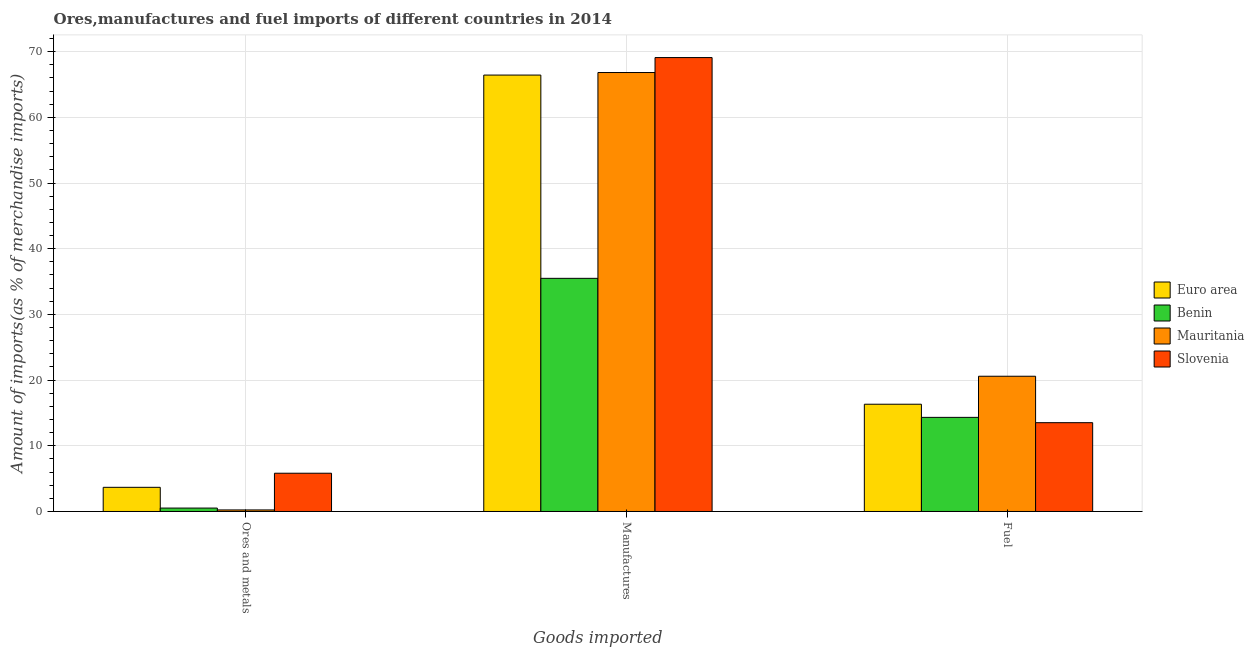How many groups of bars are there?
Your response must be concise. 3. Are the number of bars per tick equal to the number of legend labels?
Your answer should be compact. Yes. How many bars are there on the 2nd tick from the right?
Provide a succinct answer. 4. What is the label of the 2nd group of bars from the left?
Keep it short and to the point. Manufactures. What is the percentage of fuel imports in Slovenia?
Provide a short and direct response. 13.52. Across all countries, what is the maximum percentage of fuel imports?
Provide a succinct answer. 20.59. Across all countries, what is the minimum percentage of fuel imports?
Your response must be concise. 13.52. In which country was the percentage of manufactures imports maximum?
Keep it short and to the point. Slovenia. In which country was the percentage of ores and metals imports minimum?
Offer a very short reply. Mauritania. What is the total percentage of ores and metals imports in the graph?
Offer a terse response. 10.26. What is the difference between the percentage of ores and metals imports in Benin and that in Mauritania?
Ensure brevity in your answer.  0.28. What is the difference between the percentage of manufactures imports in Mauritania and the percentage of ores and metals imports in Benin?
Give a very brief answer. 66.3. What is the average percentage of fuel imports per country?
Ensure brevity in your answer.  16.19. What is the difference between the percentage of manufactures imports and percentage of fuel imports in Slovenia?
Make the answer very short. 55.58. What is the ratio of the percentage of fuel imports in Euro area to that in Slovenia?
Offer a very short reply. 1.21. Is the percentage of manufactures imports in Euro area less than that in Mauritania?
Make the answer very short. Yes. What is the difference between the highest and the second highest percentage of manufactures imports?
Keep it short and to the point. 2.28. What is the difference between the highest and the lowest percentage of manufactures imports?
Provide a succinct answer. 33.61. In how many countries, is the percentage of ores and metals imports greater than the average percentage of ores and metals imports taken over all countries?
Provide a short and direct response. 2. Is the sum of the percentage of manufactures imports in Benin and Slovenia greater than the maximum percentage of ores and metals imports across all countries?
Offer a very short reply. Yes. What does the 3rd bar from the left in Manufactures represents?
Ensure brevity in your answer.  Mauritania. What does the 1st bar from the right in Ores and metals represents?
Your answer should be compact. Slovenia. Are all the bars in the graph horizontal?
Provide a succinct answer. No. How many countries are there in the graph?
Provide a short and direct response. 4. Are the values on the major ticks of Y-axis written in scientific E-notation?
Provide a short and direct response. No. Does the graph contain any zero values?
Keep it short and to the point. No. How many legend labels are there?
Make the answer very short. 4. How are the legend labels stacked?
Your response must be concise. Vertical. What is the title of the graph?
Your answer should be very brief. Ores,manufactures and fuel imports of different countries in 2014. What is the label or title of the X-axis?
Your answer should be compact. Goods imported. What is the label or title of the Y-axis?
Offer a terse response. Amount of imports(as % of merchandise imports). What is the Amount of imports(as % of merchandise imports) in Euro area in Ores and metals?
Make the answer very short. 3.68. What is the Amount of imports(as % of merchandise imports) of Benin in Ores and metals?
Offer a terse response. 0.52. What is the Amount of imports(as % of merchandise imports) in Mauritania in Ores and metals?
Give a very brief answer. 0.24. What is the Amount of imports(as % of merchandise imports) of Slovenia in Ores and metals?
Offer a very short reply. 5.82. What is the Amount of imports(as % of merchandise imports) of Euro area in Manufactures?
Provide a short and direct response. 66.44. What is the Amount of imports(as % of merchandise imports) in Benin in Manufactures?
Ensure brevity in your answer.  35.49. What is the Amount of imports(as % of merchandise imports) in Mauritania in Manufactures?
Make the answer very short. 66.82. What is the Amount of imports(as % of merchandise imports) in Slovenia in Manufactures?
Ensure brevity in your answer.  69.1. What is the Amount of imports(as % of merchandise imports) of Euro area in Fuel?
Provide a short and direct response. 16.33. What is the Amount of imports(as % of merchandise imports) in Benin in Fuel?
Ensure brevity in your answer.  14.33. What is the Amount of imports(as % of merchandise imports) in Mauritania in Fuel?
Provide a succinct answer. 20.59. What is the Amount of imports(as % of merchandise imports) of Slovenia in Fuel?
Ensure brevity in your answer.  13.52. Across all Goods imported, what is the maximum Amount of imports(as % of merchandise imports) in Euro area?
Make the answer very short. 66.44. Across all Goods imported, what is the maximum Amount of imports(as % of merchandise imports) in Benin?
Provide a succinct answer. 35.49. Across all Goods imported, what is the maximum Amount of imports(as % of merchandise imports) in Mauritania?
Your response must be concise. 66.82. Across all Goods imported, what is the maximum Amount of imports(as % of merchandise imports) in Slovenia?
Offer a terse response. 69.1. Across all Goods imported, what is the minimum Amount of imports(as % of merchandise imports) in Euro area?
Provide a succinct answer. 3.68. Across all Goods imported, what is the minimum Amount of imports(as % of merchandise imports) in Benin?
Provide a short and direct response. 0.52. Across all Goods imported, what is the minimum Amount of imports(as % of merchandise imports) of Mauritania?
Make the answer very short. 0.24. Across all Goods imported, what is the minimum Amount of imports(as % of merchandise imports) in Slovenia?
Provide a short and direct response. 5.82. What is the total Amount of imports(as % of merchandise imports) of Euro area in the graph?
Your answer should be compact. 86.44. What is the total Amount of imports(as % of merchandise imports) of Benin in the graph?
Provide a succinct answer. 50.34. What is the total Amount of imports(as % of merchandise imports) of Mauritania in the graph?
Make the answer very short. 87.64. What is the total Amount of imports(as % of merchandise imports) in Slovenia in the graph?
Provide a succinct answer. 88.44. What is the difference between the Amount of imports(as % of merchandise imports) in Euro area in Ores and metals and that in Manufactures?
Make the answer very short. -62.76. What is the difference between the Amount of imports(as % of merchandise imports) of Benin in Ores and metals and that in Manufactures?
Your answer should be compact. -34.97. What is the difference between the Amount of imports(as % of merchandise imports) in Mauritania in Ores and metals and that in Manufactures?
Provide a short and direct response. -66.59. What is the difference between the Amount of imports(as % of merchandise imports) of Slovenia in Ores and metals and that in Manufactures?
Keep it short and to the point. -63.27. What is the difference between the Amount of imports(as % of merchandise imports) in Euro area in Ores and metals and that in Fuel?
Keep it short and to the point. -12.65. What is the difference between the Amount of imports(as % of merchandise imports) in Benin in Ores and metals and that in Fuel?
Make the answer very short. -13.81. What is the difference between the Amount of imports(as % of merchandise imports) in Mauritania in Ores and metals and that in Fuel?
Offer a terse response. -20.35. What is the difference between the Amount of imports(as % of merchandise imports) of Slovenia in Ores and metals and that in Fuel?
Offer a terse response. -7.7. What is the difference between the Amount of imports(as % of merchandise imports) in Euro area in Manufactures and that in Fuel?
Your response must be concise. 50.11. What is the difference between the Amount of imports(as % of merchandise imports) of Benin in Manufactures and that in Fuel?
Provide a succinct answer. 21.17. What is the difference between the Amount of imports(as % of merchandise imports) of Mauritania in Manufactures and that in Fuel?
Offer a very short reply. 46.23. What is the difference between the Amount of imports(as % of merchandise imports) of Slovenia in Manufactures and that in Fuel?
Offer a terse response. 55.58. What is the difference between the Amount of imports(as % of merchandise imports) in Euro area in Ores and metals and the Amount of imports(as % of merchandise imports) in Benin in Manufactures?
Offer a very short reply. -31.81. What is the difference between the Amount of imports(as % of merchandise imports) in Euro area in Ores and metals and the Amount of imports(as % of merchandise imports) in Mauritania in Manufactures?
Your answer should be very brief. -63.14. What is the difference between the Amount of imports(as % of merchandise imports) in Euro area in Ores and metals and the Amount of imports(as % of merchandise imports) in Slovenia in Manufactures?
Provide a succinct answer. -65.42. What is the difference between the Amount of imports(as % of merchandise imports) in Benin in Ores and metals and the Amount of imports(as % of merchandise imports) in Mauritania in Manufactures?
Give a very brief answer. -66.3. What is the difference between the Amount of imports(as % of merchandise imports) in Benin in Ores and metals and the Amount of imports(as % of merchandise imports) in Slovenia in Manufactures?
Provide a succinct answer. -68.58. What is the difference between the Amount of imports(as % of merchandise imports) of Mauritania in Ores and metals and the Amount of imports(as % of merchandise imports) of Slovenia in Manufactures?
Your response must be concise. -68.86. What is the difference between the Amount of imports(as % of merchandise imports) of Euro area in Ores and metals and the Amount of imports(as % of merchandise imports) of Benin in Fuel?
Make the answer very short. -10.65. What is the difference between the Amount of imports(as % of merchandise imports) in Euro area in Ores and metals and the Amount of imports(as % of merchandise imports) in Mauritania in Fuel?
Ensure brevity in your answer.  -16.91. What is the difference between the Amount of imports(as % of merchandise imports) in Euro area in Ores and metals and the Amount of imports(as % of merchandise imports) in Slovenia in Fuel?
Offer a very short reply. -9.84. What is the difference between the Amount of imports(as % of merchandise imports) in Benin in Ores and metals and the Amount of imports(as % of merchandise imports) in Mauritania in Fuel?
Make the answer very short. -20.07. What is the difference between the Amount of imports(as % of merchandise imports) of Benin in Ores and metals and the Amount of imports(as % of merchandise imports) of Slovenia in Fuel?
Your answer should be very brief. -13. What is the difference between the Amount of imports(as % of merchandise imports) in Mauritania in Ores and metals and the Amount of imports(as % of merchandise imports) in Slovenia in Fuel?
Your answer should be compact. -13.28. What is the difference between the Amount of imports(as % of merchandise imports) of Euro area in Manufactures and the Amount of imports(as % of merchandise imports) of Benin in Fuel?
Ensure brevity in your answer.  52.11. What is the difference between the Amount of imports(as % of merchandise imports) of Euro area in Manufactures and the Amount of imports(as % of merchandise imports) of Mauritania in Fuel?
Keep it short and to the point. 45.85. What is the difference between the Amount of imports(as % of merchandise imports) in Euro area in Manufactures and the Amount of imports(as % of merchandise imports) in Slovenia in Fuel?
Your response must be concise. 52.92. What is the difference between the Amount of imports(as % of merchandise imports) in Benin in Manufactures and the Amount of imports(as % of merchandise imports) in Mauritania in Fuel?
Your answer should be compact. 14.91. What is the difference between the Amount of imports(as % of merchandise imports) in Benin in Manufactures and the Amount of imports(as % of merchandise imports) in Slovenia in Fuel?
Give a very brief answer. 21.97. What is the difference between the Amount of imports(as % of merchandise imports) of Mauritania in Manufactures and the Amount of imports(as % of merchandise imports) of Slovenia in Fuel?
Give a very brief answer. 53.3. What is the average Amount of imports(as % of merchandise imports) in Euro area per Goods imported?
Your response must be concise. 28.81. What is the average Amount of imports(as % of merchandise imports) in Benin per Goods imported?
Provide a succinct answer. 16.78. What is the average Amount of imports(as % of merchandise imports) in Mauritania per Goods imported?
Provide a short and direct response. 29.21. What is the average Amount of imports(as % of merchandise imports) in Slovenia per Goods imported?
Provide a short and direct response. 29.48. What is the difference between the Amount of imports(as % of merchandise imports) of Euro area and Amount of imports(as % of merchandise imports) of Benin in Ores and metals?
Provide a succinct answer. 3.16. What is the difference between the Amount of imports(as % of merchandise imports) of Euro area and Amount of imports(as % of merchandise imports) of Mauritania in Ores and metals?
Your response must be concise. 3.44. What is the difference between the Amount of imports(as % of merchandise imports) in Euro area and Amount of imports(as % of merchandise imports) in Slovenia in Ores and metals?
Ensure brevity in your answer.  -2.15. What is the difference between the Amount of imports(as % of merchandise imports) in Benin and Amount of imports(as % of merchandise imports) in Mauritania in Ores and metals?
Offer a very short reply. 0.28. What is the difference between the Amount of imports(as % of merchandise imports) of Benin and Amount of imports(as % of merchandise imports) of Slovenia in Ores and metals?
Your answer should be compact. -5.31. What is the difference between the Amount of imports(as % of merchandise imports) of Mauritania and Amount of imports(as % of merchandise imports) of Slovenia in Ores and metals?
Your answer should be very brief. -5.59. What is the difference between the Amount of imports(as % of merchandise imports) of Euro area and Amount of imports(as % of merchandise imports) of Benin in Manufactures?
Your answer should be compact. 30.94. What is the difference between the Amount of imports(as % of merchandise imports) in Euro area and Amount of imports(as % of merchandise imports) in Mauritania in Manufactures?
Offer a very short reply. -0.39. What is the difference between the Amount of imports(as % of merchandise imports) of Euro area and Amount of imports(as % of merchandise imports) of Slovenia in Manufactures?
Offer a very short reply. -2.66. What is the difference between the Amount of imports(as % of merchandise imports) of Benin and Amount of imports(as % of merchandise imports) of Mauritania in Manufactures?
Make the answer very short. -31.33. What is the difference between the Amount of imports(as % of merchandise imports) of Benin and Amount of imports(as % of merchandise imports) of Slovenia in Manufactures?
Your response must be concise. -33.61. What is the difference between the Amount of imports(as % of merchandise imports) in Mauritania and Amount of imports(as % of merchandise imports) in Slovenia in Manufactures?
Provide a succinct answer. -2.28. What is the difference between the Amount of imports(as % of merchandise imports) in Euro area and Amount of imports(as % of merchandise imports) in Benin in Fuel?
Make the answer very short. 2. What is the difference between the Amount of imports(as % of merchandise imports) in Euro area and Amount of imports(as % of merchandise imports) in Mauritania in Fuel?
Your answer should be compact. -4.26. What is the difference between the Amount of imports(as % of merchandise imports) of Euro area and Amount of imports(as % of merchandise imports) of Slovenia in Fuel?
Keep it short and to the point. 2.81. What is the difference between the Amount of imports(as % of merchandise imports) in Benin and Amount of imports(as % of merchandise imports) in Mauritania in Fuel?
Give a very brief answer. -6.26. What is the difference between the Amount of imports(as % of merchandise imports) of Benin and Amount of imports(as % of merchandise imports) of Slovenia in Fuel?
Offer a terse response. 0.81. What is the difference between the Amount of imports(as % of merchandise imports) in Mauritania and Amount of imports(as % of merchandise imports) in Slovenia in Fuel?
Keep it short and to the point. 7.07. What is the ratio of the Amount of imports(as % of merchandise imports) in Euro area in Ores and metals to that in Manufactures?
Your answer should be compact. 0.06. What is the ratio of the Amount of imports(as % of merchandise imports) in Benin in Ores and metals to that in Manufactures?
Provide a short and direct response. 0.01. What is the ratio of the Amount of imports(as % of merchandise imports) of Mauritania in Ores and metals to that in Manufactures?
Keep it short and to the point. 0. What is the ratio of the Amount of imports(as % of merchandise imports) in Slovenia in Ores and metals to that in Manufactures?
Your answer should be very brief. 0.08. What is the ratio of the Amount of imports(as % of merchandise imports) of Euro area in Ores and metals to that in Fuel?
Provide a succinct answer. 0.23. What is the ratio of the Amount of imports(as % of merchandise imports) of Benin in Ores and metals to that in Fuel?
Your answer should be compact. 0.04. What is the ratio of the Amount of imports(as % of merchandise imports) in Mauritania in Ores and metals to that in Fuel?
Provide a short and direct response. 0.01. What is the ratio of the Amount of imports(as % of merchandise imports) of Slovenia in Ores and metals to that in Fuel?
Your answer should be very brief. 0.43. What is the ratio of the Amount of imports(as % of merchandise imports) of Euro area in Manufactures to that in Fuel?
Give a very brief answer. 4.07. What is the ratio of the Amount of imports(as % of merchandise imports) in Benin in Manufactures to that in Fuel?
Your response must be concise. 2.48. What is the ratio of the Amount of imports(as % of merchandise imports) in Mauritania in Manufactures to that in Fuel?
Provide a succinct answer. 3.25. What is the ratio of the Amount of imports(as % of merchandise imports) in Slovenia in Manufactures to that in Fuel?
Provide a short and direct response. 5.11. What is the difference between the highest and the second highest Amount of imports(as % of merchandise imports) of Euro area?
Offer a very short reply. 50.11. What is the difference between the highest and the second highest Amount of imports(as % of merchandise imports) in Benin?
Give a very brief answer. 21.17. What is the difference between the highest and the second highest Amount of imports(as % of merchandise imports) in Mauritania?
Offer a very short reply. 46.23. What is the difference between the highest and the second highest Amount of imports(as % of merchandise imports) of Slovenia?
Make the answer very short. 55.58. What is the difference between the highest and the lowest Amount of imports(as % of merchandise imports) in Euro area?
Make the answer very short. 62.76. What is the difference between the highest and the lowest Amount of imports(as % of merchandise imports) in Benin?
Provide a succinct answer. 34.97. What is the difference between the highest and the lowest Amount of imports(as % of merchandise imports) in Mauritania?
Provide a short and direct response. 66.59. What is the difference between the highest and the lowest Amount of imports(as % of merchandise imports) in Slovenia?
Make the answer very short. 63.27. 